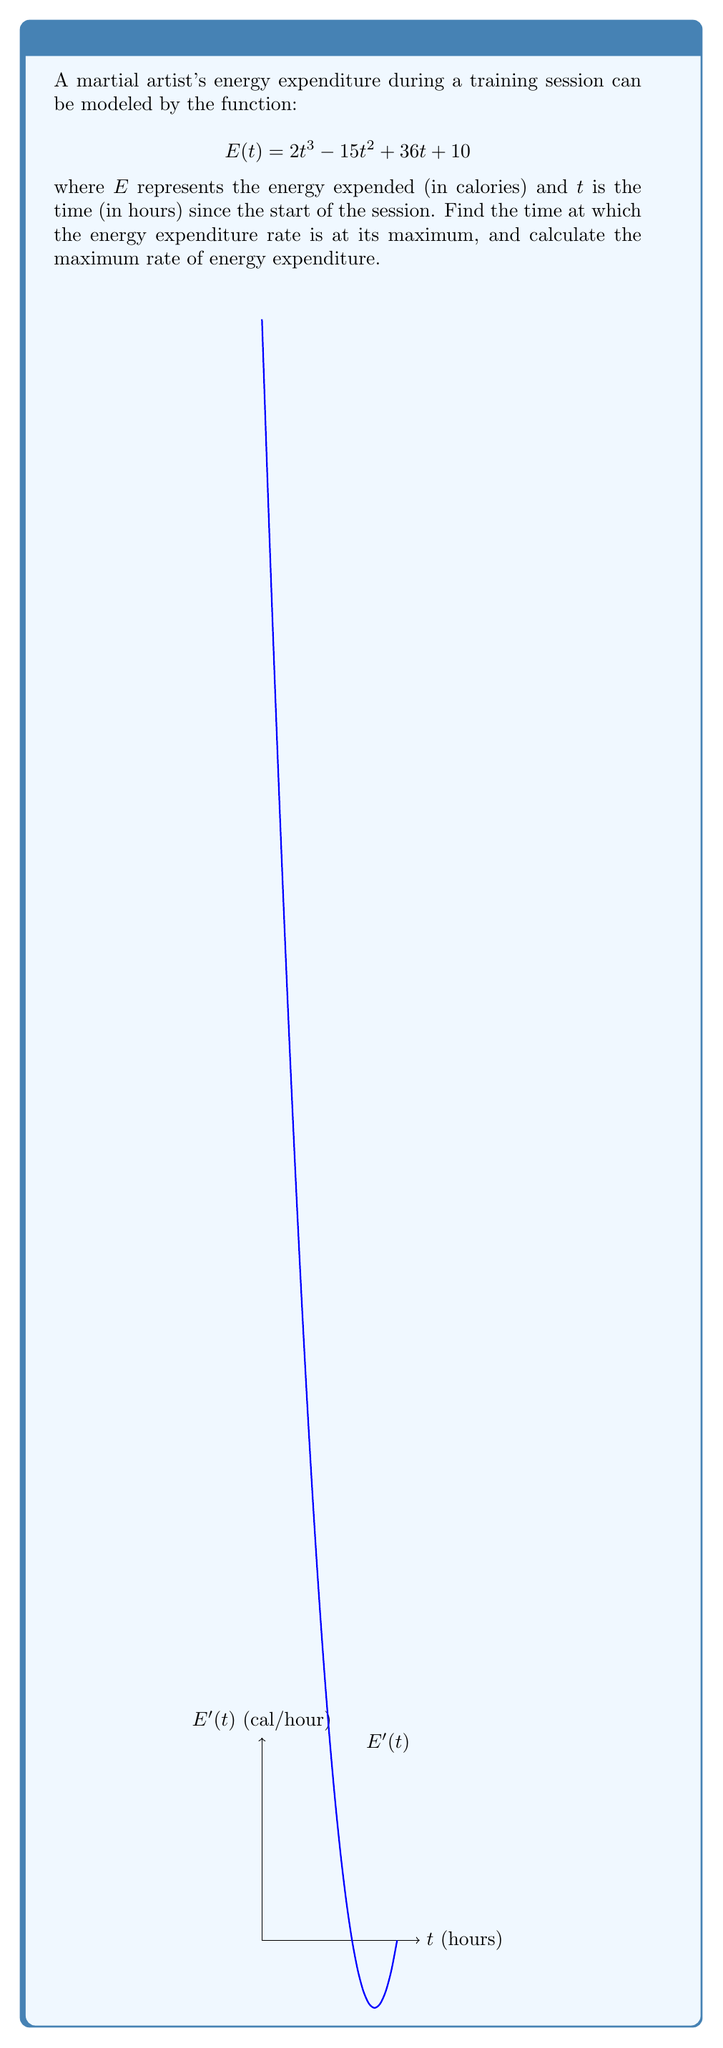Help me with this question. To find the maximum efficiency point, we need to follow these steps:

1) First, we need to find the rate of energy expenditure, which is the derivative of $E(t)$:

   $$E'(t) = 6t^2 - 30t + 36$$

2) The maximum rate occurs where the second derivative equals zero. So, let's find $E''(t)$:

   $$E''(t) = 12t - 30$$

3) Set $E''(t) = 0$ and solve for $t$:

   $$12t - 30 = 0$$
   $$12t = 30$$
   $$t = \frac{30}{12} = 2.5$$

4) To confirm this is a maximum (not a minimum), we can check that $E'''(t) = 12 > 0$.

5) Now that we know the time of maximum efficiency (2.5 hours), we can calculate the maximum rate by plugging this value back into $E'(t)$:

   $$E'(2.5) = 6(2.5)^2 - 30(2.5) + 36$$
   $$= 6(6.25) - 75 + 36$$
   $$= 37.5 - 75 + 36$$
   $$= -1.5$$

Therefore, the maximum rate of energy expenditure occurs at 2.5 hours into the training session, and the rate at that point is -1.5 calories per hour.
Answer: Maximum efficiency at $t = 2.5$ hours; Maximum rate $= -1.5$ cal/hour 